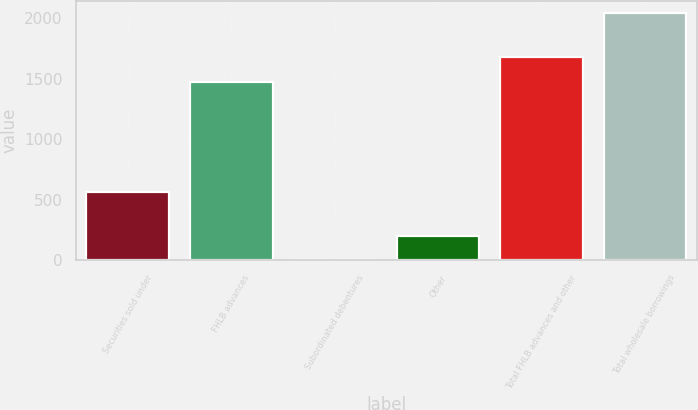<chart> <loc_0><loc_0><loc_500><loc_500><bar_chart><fcel>Securities sold under<fcel>FHLB advances<fcel>Subordinated debentures<fcel>Other<fcel>Total FHLB advances and other<fcel>Total wholesale borrowings<nl><fcel>560.8<fcel>1471<fcel>0.1<fcel>203.77<fcel>1674.67<fcel>2036.8<nl></chart> 